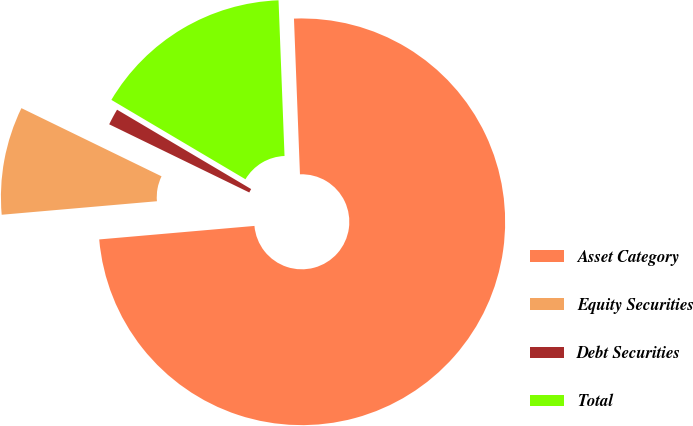Convert chart to OTSL. <chart><loc_0><loc_0><loc_500><loc_500><pie_chart><fcel>Asset Category<fcel>Equity Securities<fcel>Debt Securities<fcel>Total<nl><fcel>74.23%<fcel>8.59%<fcel>1.3%<fcel>15.88%<nl></chart> 